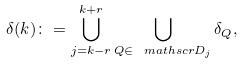Convert formula to latex. <formula><loc_0><loc_0><loc_500><loc_500>\delta ( k ) \colon = \bigcup _ { j = k - r } ^ { k + r } \bigcup _ { Q \in \ m a t h s c r { D } _ { j } } \delta _ { Q } ,</formula> 